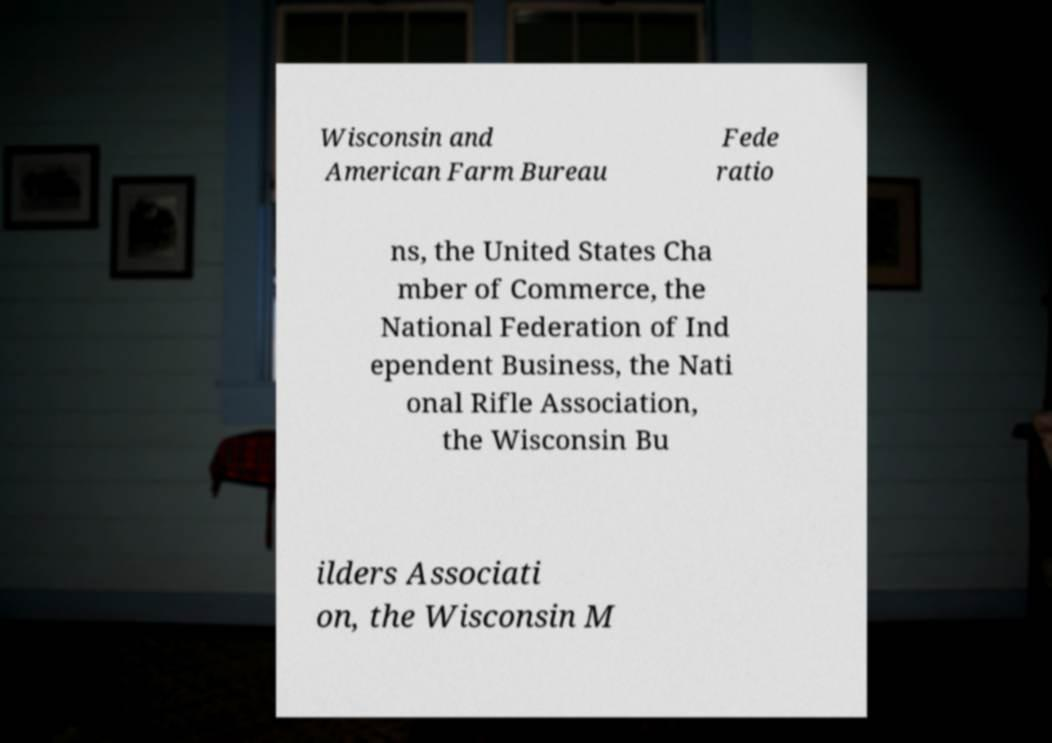Could you assist in decoding the text presented in this image and type it out clearly? Wisconsin and American Farm Bureau Fede ratio ns, the United States Cha mber of Commerce, the National Federation of Ind ependent Business, the Nati onal Rifle Association, the Wisconsin Bu ilders Associati on, the Wisconsin M 